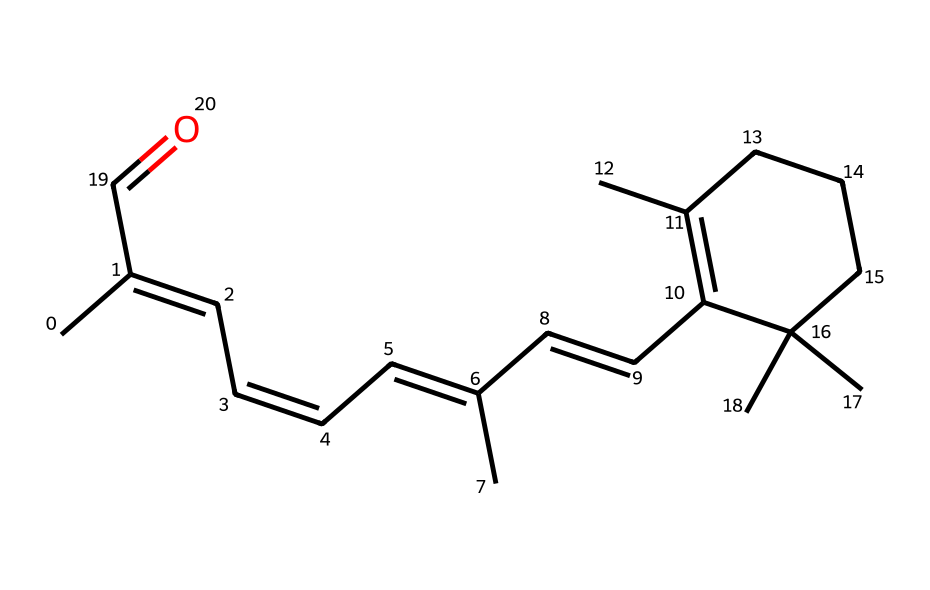What is the molecular formula of retinal? By analyzing the structure represented in the SMILES notation, the apparent atoms can be counted. There are 20 carbon (C) atoms, 28 hydrogen (H) atoms, and 1 oxygen (O) atom, leading to the molecular formula C20H28O.
Answer: C20H28O How many double bonds are present in the structure of retinal? From the SMILES representation, we can locate the "=" symbols which denote double bonds. By examining the structure, we find there are five double bonds in retinal.
Answer: 5 What type of isomerism is exhibited by retinal? Retinal contains multiple double bonds that create the potential for geometric isomerism due to different spatial arrangements around these bonds, specifically cis and trans configurations.
Answer: geometric isomerism Which geometric isomers of retinal are most relevant in vision? The specific geometric isomers pertinent to vision are the all-trans and 11-cis forms of retinal. These isomers play critical roles in the visual cycle by interacting with opsins in photoreceptor cells.
Answer: all-trans and 11-cis How does the configuration of retinal influence its function in vision? The configuration of retinal, particularly whether it is in the all-trans or 11-cis form, affects the conformation of opsins which alters their ability to capture light, a fundamental process in visual signal transduction.
Answer: influences opsin conformation 